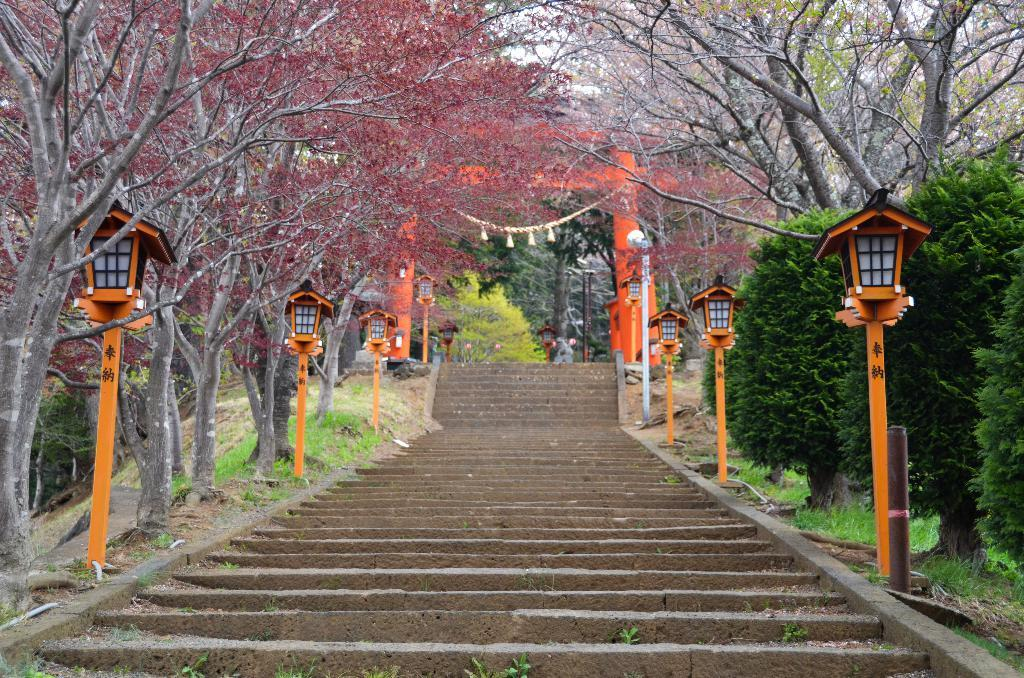What celestial objects can be seen in the image? There are stars visible in the image. What type of lighting is present in the image? There are lamps in the image. What type of vegetation is on the left side of the image? There are trees on the left side of the image. What type of vegetation is on the right side of the image? There are trees on the right side of the image. What architectural feature can be seen in the background of the image? There is an arch in the background of the image. What is the purpose of the fairies in the image? There are no fairies present in the image, so it is not possible to determine their purpose. 